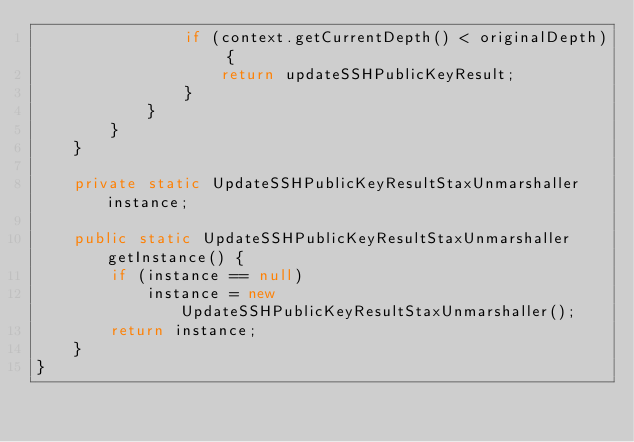Convert code to text. <code><loc_0><loc_0><loc_500><loc_500><_Java_>                if (context.getCurrentDepth() < originalDepth) {
                    return updateSSHPublicKeyResult;
                }
            }
        }
    }

    private static UpdateSSHPublicKeyResultStaxUnmarshaller instance;

    public static UpdateSSHPublicKeyResultStaxUnmarshaller getInstance() {
        if (instance == null)
            instance = new UpdateSSHPublicKeyResultStaxUnmarshaller();
        return instance;
    }
}
</code> 